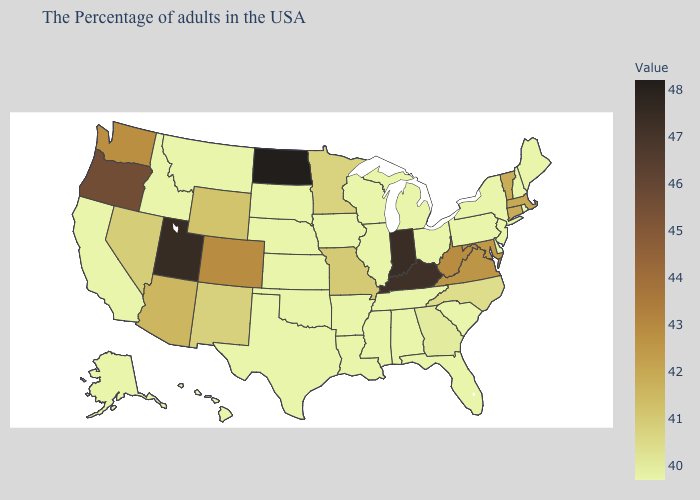Does New Jersey have the highest value in the USA?
Give a very brief answer. No. Which states hav the highest value in the West?
Be succinct. Utah. Among the states that border Utah , does Wyoming have the lowest value?
Give a very brief answer. No. Which states have the lowest value in the MidWest?
Give a very brief answer. Ohio, Michigan, Wisconsin, Illinois, Iowa, Kansas, Nebraska, South Dakota. Does New Mexico have the lowest value in the West?
Write a very short answer. No. Does Minnesota have the lowest value in the MidWest?
Be succinct. No. Which states have the highest value in the USA?
Short answer required. North Dakota. 